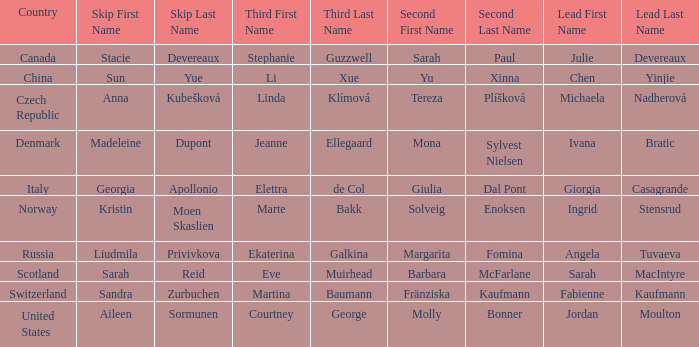Help me parse the entirety of this table. {'header': ['Country', 'Skip First Name', 'Skip Last Name', 'Third First Name', 'Third Last Name', 'Second First Name', 'Second Last Name', 'Lead First Name', 'Lead Last Name'], 'rows': [['Canada', 'Stacie', 'Devereaux', 'Stephanie', 'Guzzwell', 'Sarah', 'Paul', 'Julie', 'Devereaux'], ['China', 'Sun', 'Yue', 'Li', 'Xue', 'Yu', 'Xinna', 'Chen', 'Yinjie'], ['Czech Republic', 'Anna', 'Kubešková', 'Linda', 'Klímová', 'Tereza', 'Plíšková', 'Michaela', 'Nadherová'], ['Denmark', 'Madeleine', 'Dupont', 'Jeanne', 'Ellegaard', 'Mona', 'Sylvest Nielsen', 'Ivana', 'Bratic'], ['Italy', 'Georgia', 'Apollonio', 'Elettra', 'de Col', 'Giulia', 'Dal Pont', 'Giorgia', 'Casagrande'], ['Norway', 'Kristin', 'Moen Skaslien', 'Marte', 'Bakk', 'Solveig', 'Enoksen', 'Ingrid', 'Stensrud'], ['Russia', 'Liudmila', 'Privivkova', 'Ekaterina', 'Galkina', 'Margarita', 'Fomina', 'Angela', 'Tuvaeva'], ['Scotland', 'Sarah', 'Reid', 'Eve', 'Muirhead', 'Barbara', 'McFarlane', 'Sarah', 'MacIntyre'], ['Switzerland', 'Sandra', 'Zurbuchen', 'Martina', 'Baumann', 'Fränziska', 'Kaufmann', 'Fabienne', 'Kaufmann'], ['United States', 'Aileen', 'Sormunen', 'Courtney', 'George', 'Molly', 'Bonner', 'Jordan', 'Moulton']]} What is the second that has jordan moulton as the lead? Molly Bonner. 